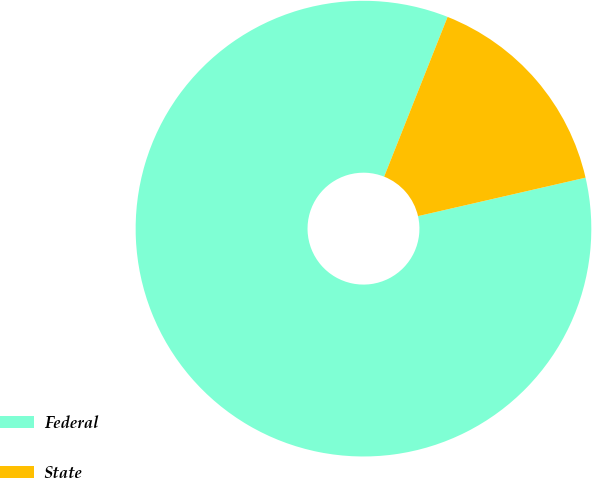Convert chart. <chart><loc_0><loc_0><loc_500><loc_500><pie_chart><fcel>Federal<fcel>State<nl><fcel>84.61%<fcel>15.39%<nl></chart> 